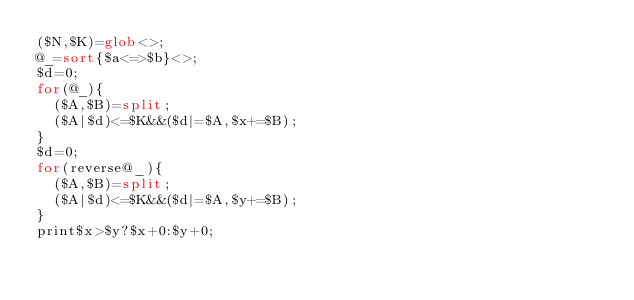<code> <loc_0><loc_0><loc_500><loc_500><_Perl_>($N,$K)=glob<>;
@_=sort{$a<=>$b}<>;
$d=0;
for(@_){
	($A,$B)=split;
	($A|$d)<=$K&&($d|=$A,$x+=$B);
}
$d=0;
for(reverse@_){
	($A,$B)=split;
	($A|$d)<=$K&&($d|=$A,$y+=$B);
}
print$x>$y?$x+0:$y+0;
</code> 